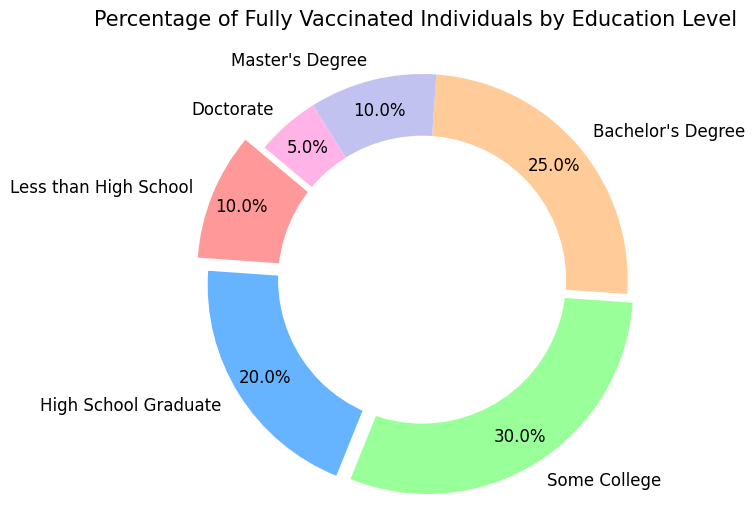What percentage of fully vaccinated individuals have at least a Bachelor's Degree? Add the percentages of those with a Bachelor's Degree, Master's Degree, and Doctorate. 25% (Bachelor's Degree) + 10% (Master's Degree) + 5% (Doctorate) = 40%
Answer: 40% Which education level has the highest percentage of fully vaccinated individuals? Observe the segment sizes or percentages labeled in the pie chart. "Some College" has the highest percentage at 30%.
Answer: Some College By how much does the percentage of fully vaccinated individuals with some college education exceed those with a high school diploma? Subtract the percentage of high school graduates from those with some college education. 30% (Some College) - 20% (High School Graduate) = 10%
Answer: 10% What is the combined percentage of fully vaccinated individuals with less than a high school education and those with a doctorate? Add the percentages of those with less than a high school education and those with a doctorate. 10% (Less than High School) + 5% (Doctorate) = 15%
Answer: 15% Identify the wedge with the smallest percentage of fully vaccinated individuals and state its education level. Observe the sizes of the wedges and the corresponding labels. The "Doctorate" wedge is the smallest at 5%.
Answer: Doctorate What is the total percentage of fully vaccinated individuals who have completed up to high school education (either less than high school or a high school graduate)? Add the percentages of those with less than a high school education and high school graduates. 10% (Less than High School) + 20% (High School Graduate) = 30%
Answer: 30% Compare the percentages of fully vaccinated individuals between those with a Bachelor's Degree and a Master's Degree. Which group is higher and by how much? Subtract the percentage of individuals with a Master's Degree from those with a Bachelor's Degree. 25% (Bachelor's Degree) - 10% (Master's Degree) = 15%. The Bachelor's Degree group is higher by 15%.
Answer: Bachelor's Degree, 15% What percentage of fully vaccinated individuals have an education level of high school graduate or less? Add the percentages of those with less than a high school education and high school graduates. 10% (Less than High School) + 20% (High School Graduate) = 30%
Answer: 30% How many categories have an exact 10% of fully vaccinated individuals? Count the categories with a 10% label. There are two: "Less than High School" and "Master's Degree".
Answer: 2 What is the color of the wedge representing individuals with some college education? Identify the color of the wedge labeled "Some College". The color is green.
Answer: Green 